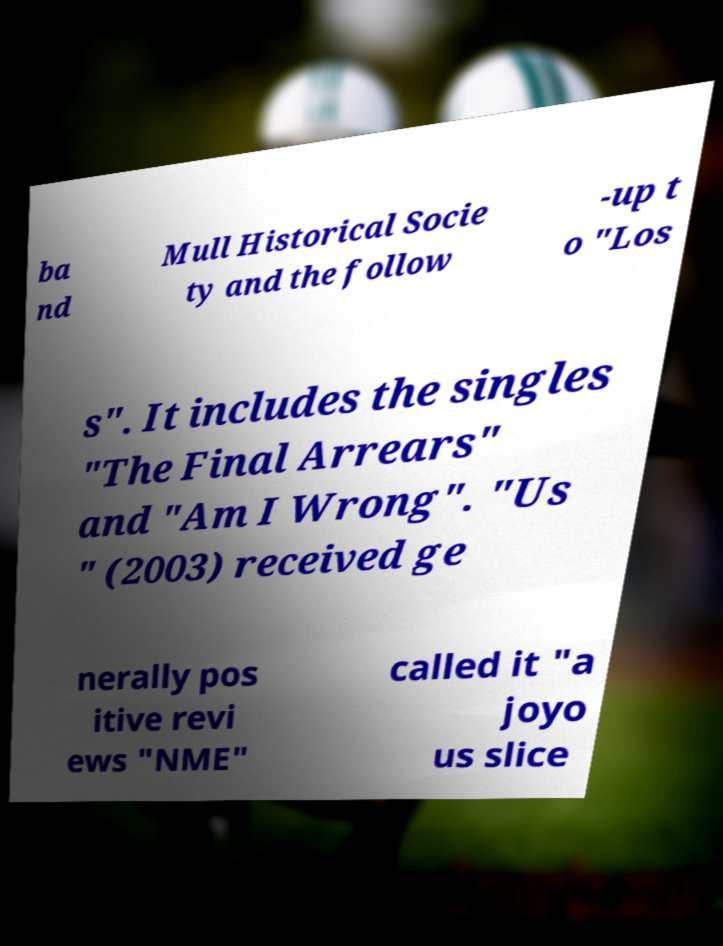Can you accurately transcribe the text from the provided image for me? ba nd Mull Historical Socie ty and the follow -up t o "Los s". It includes the singles "The Final Arrears" and "Am I Wrong". "Us " (2003) received ge nerally pos itive revi ews "NME" called it "a joyo us slice 